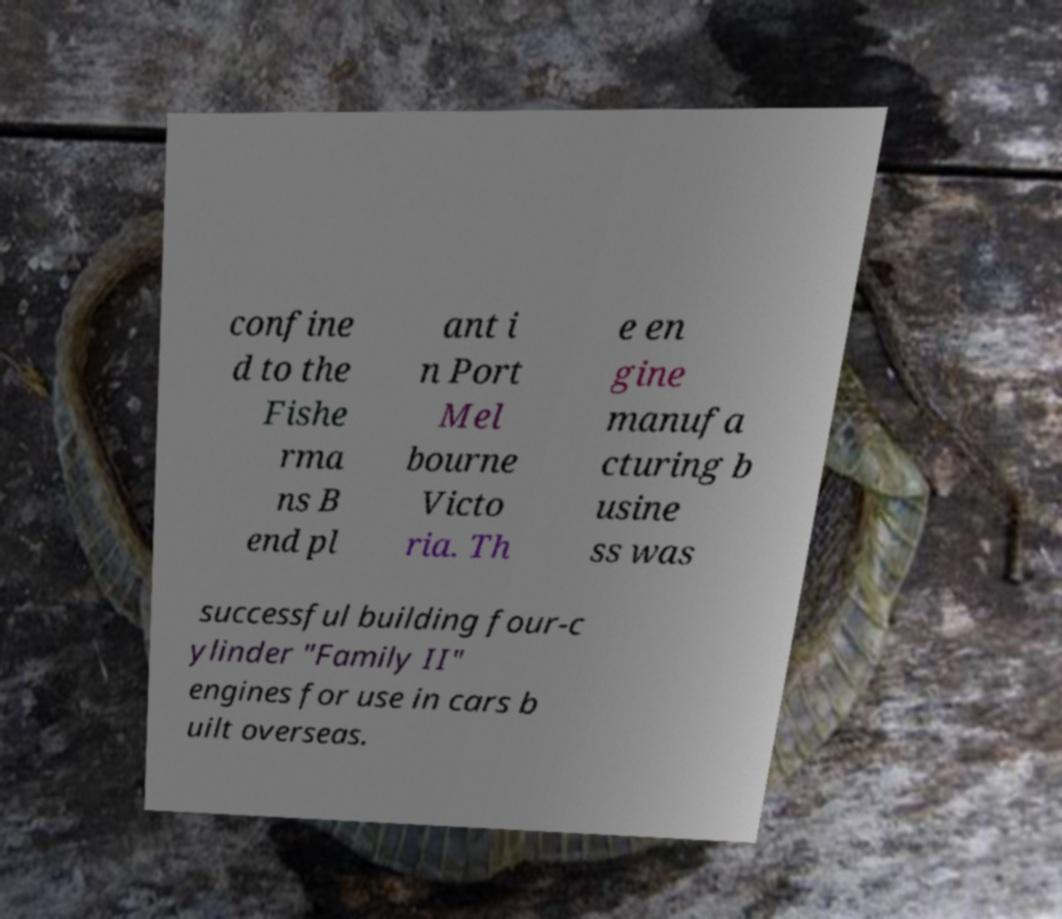Please read and relay the text visible in this image. What does it say? confine d to the Fishe rma ns B end pl ant i n Port Mel bourne Victo ria. Th e en gine manufa cturing b usine ss was successful building four-c ylinder "Family II" engines for use in cars b uilt overseas. 